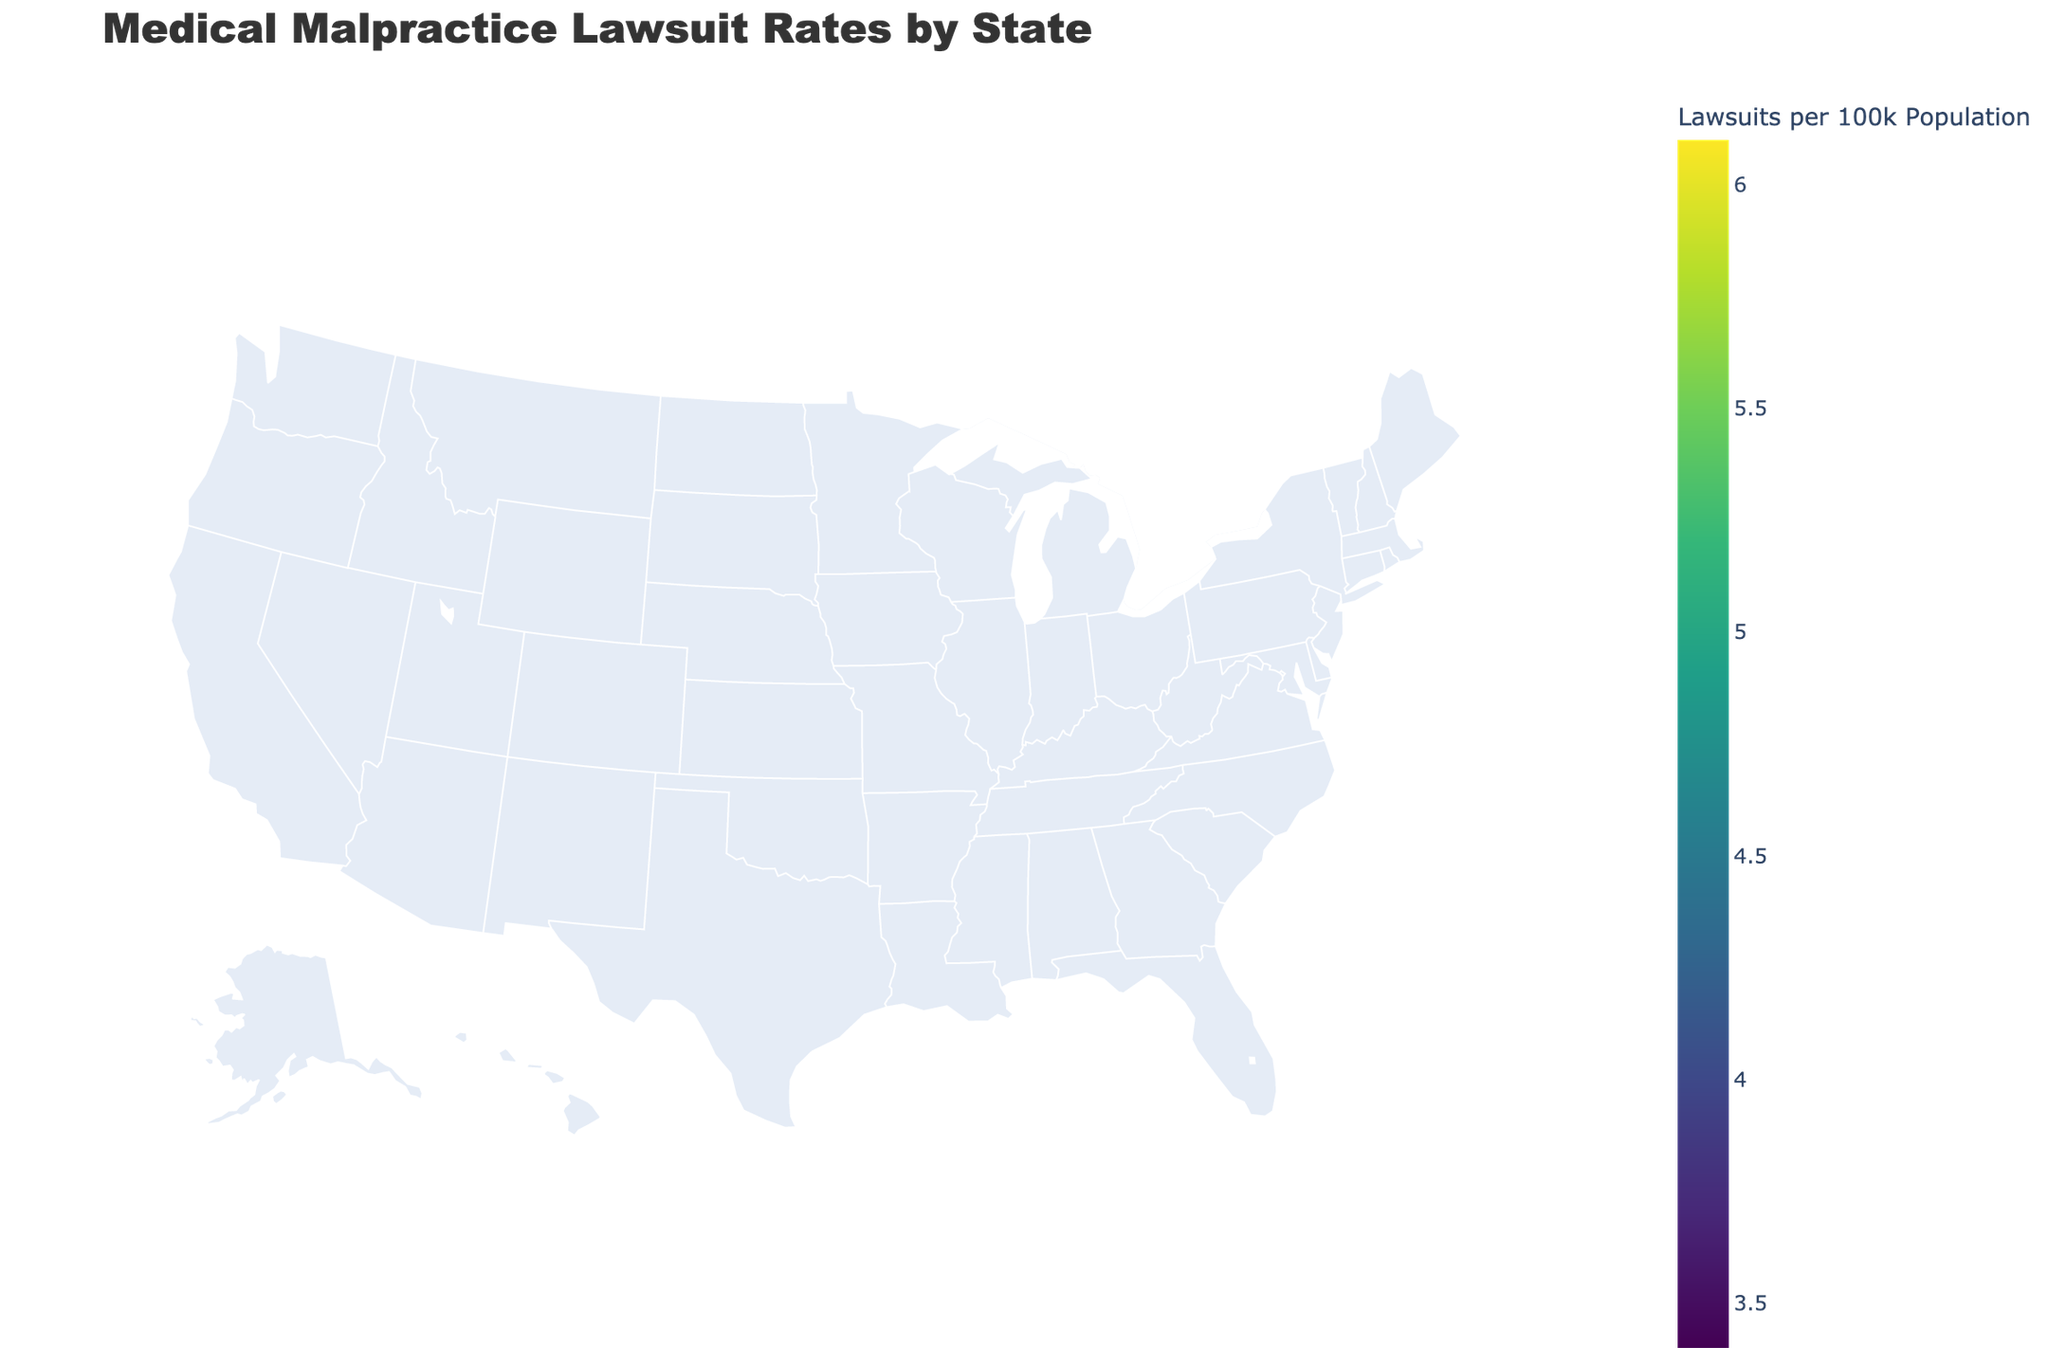What is the title of the plot? The title is typically located at the top of the figure and highlights the main subject of the plot.
Answer: Medical Malpractice Lawsuit Rates by State Which state has the highest rate of medical malpractice lawsuits per 100,000 population? By examining the color intensity in the choropleth map, identify the state with the darkest shade, then hover over it to confirm the data value.
Answer: New York How much is the average settlement amount in Texas? Find Texas on the choropleth map, hover over it to see the text data displayed, which includes the average settlement amount.
Answer: $350,000 Compare the average settlement amounts between California and New York. Which state has a higher average? Check the text data for both California and New York by hovering over these states, and compare the displayed average settlement amounts.
Answer: New York Which state has fewer lawsuits per 100,000 population: Ohio or Wisconsin? Locate Ohio and Wisconsin on the map, use the color gradient or hover over each state to see the exact values for lawsuits per 100,000 population, and then compare both values.
Answer: Wisconsin What does the color scale represent in the map? The color scale typically symbolizes a continuous value range; in this case, it indicates the rate of medical malpractice lawsuits per 100,000 population across different states.
Answer: Lawsuits per 100k Population How does the average settlement amount influence the size and color of the bubbles on the map? The size of the bubbles is proportional to the average settlement amount, and the color represents a gradient, giving a visual representation of higher or lower settlements respectively.
Answer: Larger bubbles and darker colors represent higher average settlement amounts Identify the two states with the closest average settlement amounts. Hover over each state to note the average settlement amounts, compare these values, and find the two states whose settlement figures are closest in value.
Answer: Michigan ($325,000) and North Carolina ($315,000) Which state has the lowest average settlement amount? Scan the bubbles' sizes and hover over each one to view the average settlement amounts, identifying the state with the smallest bubble and lowest value.
Answer: Minnesota What pattern do you observe between average settlement amounts and lawsuit rates? Hover over multiple states to compare lawsuit rates and average settlement amounts, and identify if higher lawsuit rates generally correspond to higher average settlements or vice versa.
Answer: States with higher lawsuit rates like New York tend to also have higher average settlement amounts 